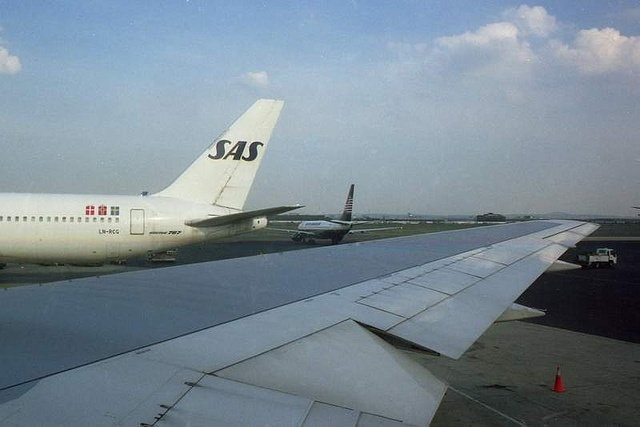Describe the objects in this image and their specific colors. I can see airplane in gray tones, airplane in gray, lightgray, and darkgray tones, airplane in gray, black, and darkgray tones, and truck in gray, black, and purple tones in this image. 